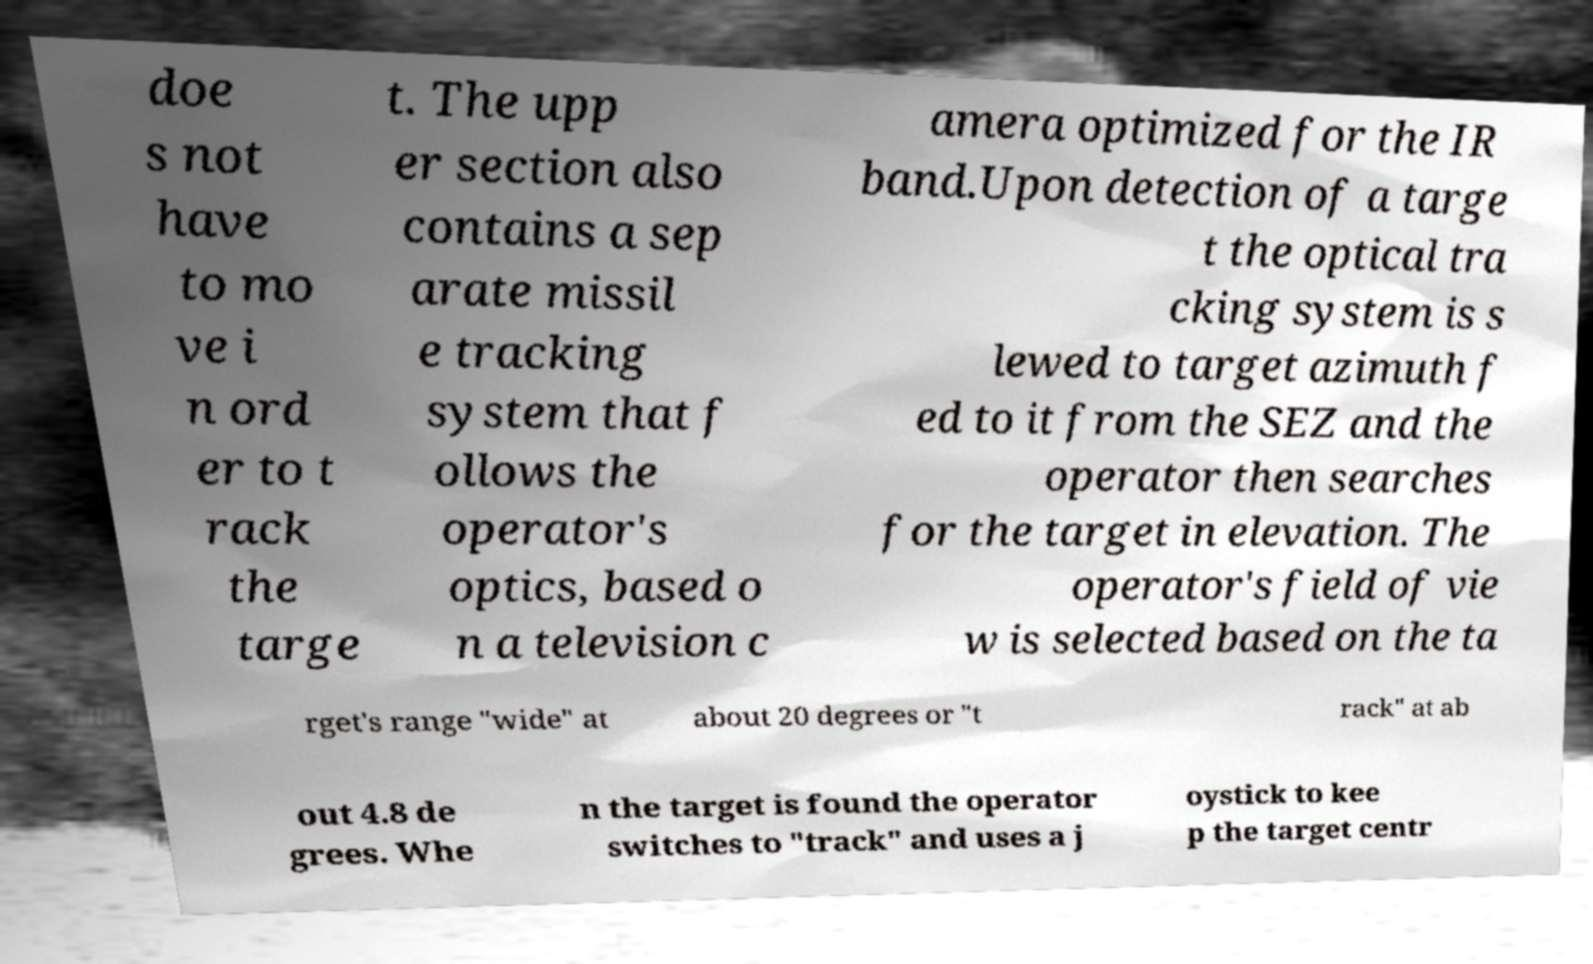Please identify and transcribe the text found in this image. doe s not have to mo ve i n ord er to t rack the targe t. The upp er section also contains a sep arate missil e tracking system that f ollows the operator's optics, based o n a television c amera optimized for the IR band.Upon detection of a targe t the optical tra cking system is s lewed to target azimuth f ed to it from the SEZ and the operator then searches for the target in elevation. The operator's field of vie w is selected based on the ta rget's range "wide" at about 20 degrees or "t rack" at ab out 4.8 de grees. Whe n the target is found the operator switches to "track" and uses a j oystick to kee p the target centr 